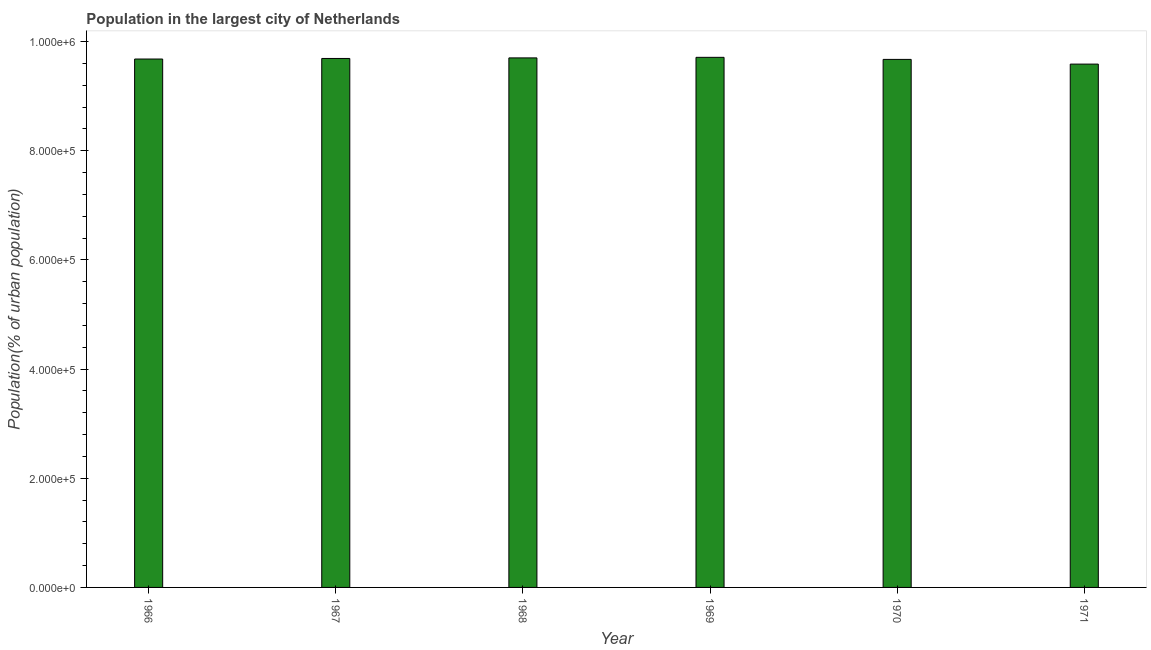What is the title of the graph?
Provide a succinct answer. Population in the largest city of Netherlands. What is the label or title of the Y-axis?
Provide a short and direct response. Population(% of urban population). What is the population in largest city in 1970?
Give a very brief answer. 9.67e+05. Across all years, what is the maximum population in largest city?
Keep it short and to the point. 9.71e+05. Across all years, what is the minimum population in largest city?
Your response must be concise. 9.59e+05. In which year was the population in largest city maximum?
Keep it short and to the point. 1969. What is the sum of the population in largest city?
Offer a very short reply. 5.81e+06. What is the difference between the population in largest city in 1966 and 1971?
Your answer should be compact. 9318. What is the average population in largest city per year?
Provide a short and direct response. 9.68e+05. What is the median population in largest city?
Keep it short and to the point. 9.69e+05. Is the difference between the population in largest city in 1966 and 1969 greater than the difference between any two years?
Make the answer very short. No. What is the difference between the highest and the second highest population in largest city?
Make the answer very short. 1030. What is the difference between the highest and the lowest population in largest city?
Your response must be concise. 1.24e+04. How many bars are there?
Ensure brevity in your answer.  6. Are all the bars in the graph horizontal?
Give a very brief answer. No. Are the values on the major ticks of Y-axis written in scientific E-notation?
Your answer should be compact. Yes. What is the Population(% of urban population) in 1966?
Your answer should be compact. 9.68e+05. What is the Population(% of urban population) in 1967?
Provide a short and direct response. 9.69e+05. What is the Population(% of urban population) in 1968?
Give a very brief answer. 9.70e+05. What is the Population(% of urban population) of 1969?
Make the answer very short. 9.71e+05. What is the Population(% of urban population) of 1970?
Provide a short and direct response. 9.67e+05. What is the Population(% of urban population) of 1971?
Offer a very short reply. 9.59e+05. What is the difference between the Population(% of urban population) in 1966 and 1967?
Provide a short and direct response. -1030. What is the difference between the Population(% of urban population) in 1966 and 1968?
Provide a succinct answer. -2063. What is the difference between the Population(% of urban population) in 1966 and 1969?
Your answer should be very brief. -3093. What is the difference between the Population(% of urban population) in 1966 and 1970?
Make the answer very short. 692. What is the difference between the Population(% of urban population) in 1966 and 1971?
Offer a terse response. 9318. What is the difference between the Population(% of urban population) in 1967 and 1968?
Offer a very short reply. -1033. What is the difference between the Population(% of urban population) in 1967 and 1969?
Provide a succinct answer. -2063. What is the difference between the Population(% of urban population) in 1967 and 1970?
Your answer should be compact. 1722. What is the difference between the Population(% of urban population) in 1967 and 1971?
Ensure brevity in your answer.  1.03e+04. What is the difference between the Population(% of urban population) in 1968 and 1969?
Your answer should be compact. -1030. What is the difference between the Population(% of urban population) in 1968 and 1970?
Offer a terse response. 2755. What is the difference between the Population(% of urban population) in 1968 and 1971?
Provide a short and direct response. 1.14e+04. What is the difference between the Population(% of urban population) in 1969 and 1970?
Provide a short and direct response. 3785. What is the difference between the Population(% of urban population) in 1969 and 1971?
Your answer should be very brief. 1.24e+04. What is the difference between the Population(% of urban population) in 1970 and 1971?
Keep it short and to the point. 8626. What is the ratio of the Population(% of urban population) in 1966 to that in 1967?
Your answer should be very brief. 1. What is the ratio of the Population(% of urban population) in 1966 to that in 1968?
Give a very brief answer. 1. What is the ratio of the Population(% of urban population) in 1966 to that in 1969?
Your answer should be very brief. 1. What is the ratio of the Population(% of urban population) in 1967 to that in 1968?
Your answer should be compact. 1. What is the ratio of the Population(% of urban population) in 1967 to that in 1971?
Keep it short and to the point. 1.01. What is the ratio of the Population(% of urban population) in 1968 to that in 1969?
Ensure brevity in your answer.  1. What is the ratio of the Population(% of urban population) in 1969 to that in 1971?
Make the answer very short. 1.01. What is the ratio of the Population(% of urban population) in 1970 to that in 1971?
Give a very brief answer. 1.01. 